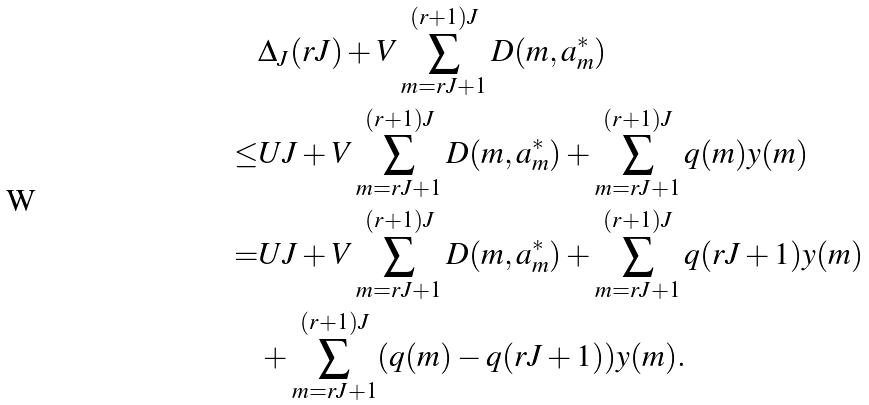<formula> <loc_0><loc_0><loc_500><loc_500>& \Delta _ { J } ( r J ) + V \sum _ { m = r J + 1 } ^ { ( r + 1 ) J } D ( m , a _ { m } ^ { * } ) \\ \leq & U J + V \sum _ { m = r J + 1 } ^ { ( r + 1 ) J } D ( m , a _ { m } ^ { * } ) + \sum _ { m = r J + 1 } ^ { ( r + 1 ) J } q ( m ) y ( m ) \\ = & U J + V \sum _ { m = r J + 1 } ^ { ( r + 1 ) J } D ( m , a _ { m } ^ { * } ) + \sum _ { m = r J + 1 } ^ { ( r + 1 ) J } q ( r J + 1 ) y ( m ) \\ & + \sum _ { m = r J + 1 } ^ { ( r + 1 ) J } ( q ( m ) - q ( r J + 1 ) ) y ( m ) .</formula> 